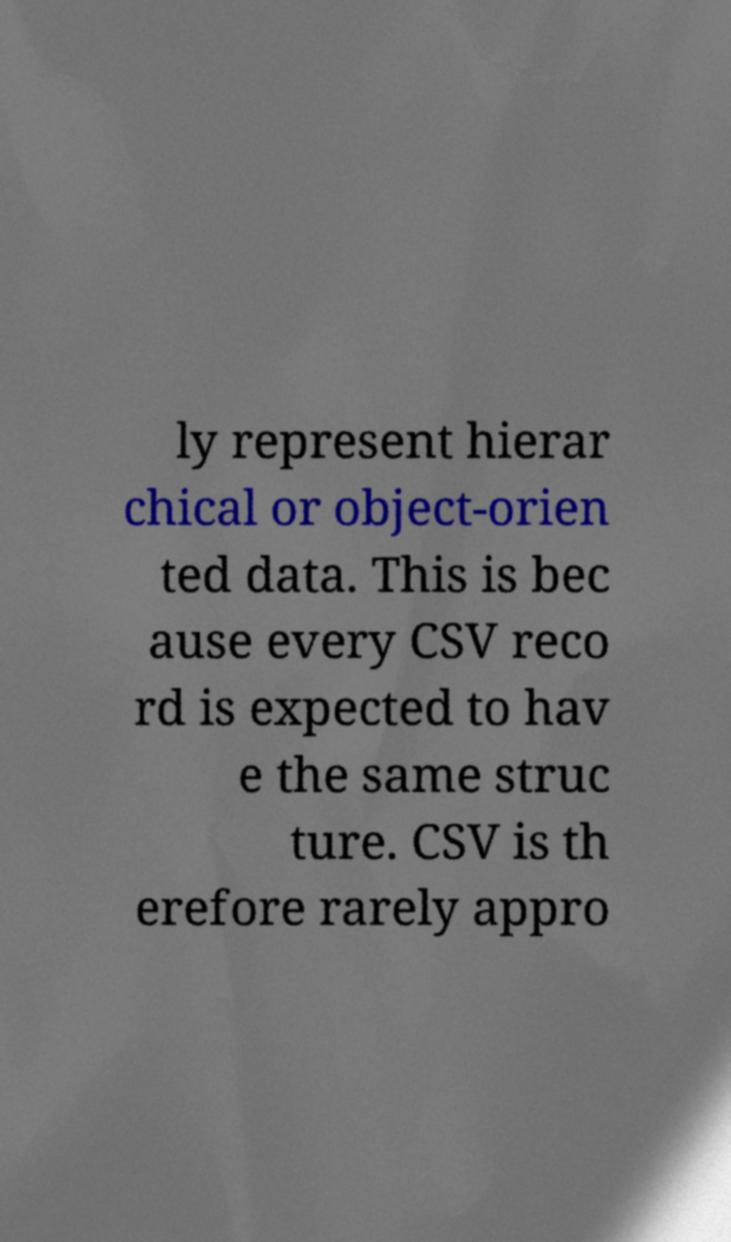Could you extract and type out the text from this image? ly represent hierar chical or object-orien ted data. This is bec ause every CSV reco rd is expected to hav e the same struc ture. CSV is th erefore rarely appro 